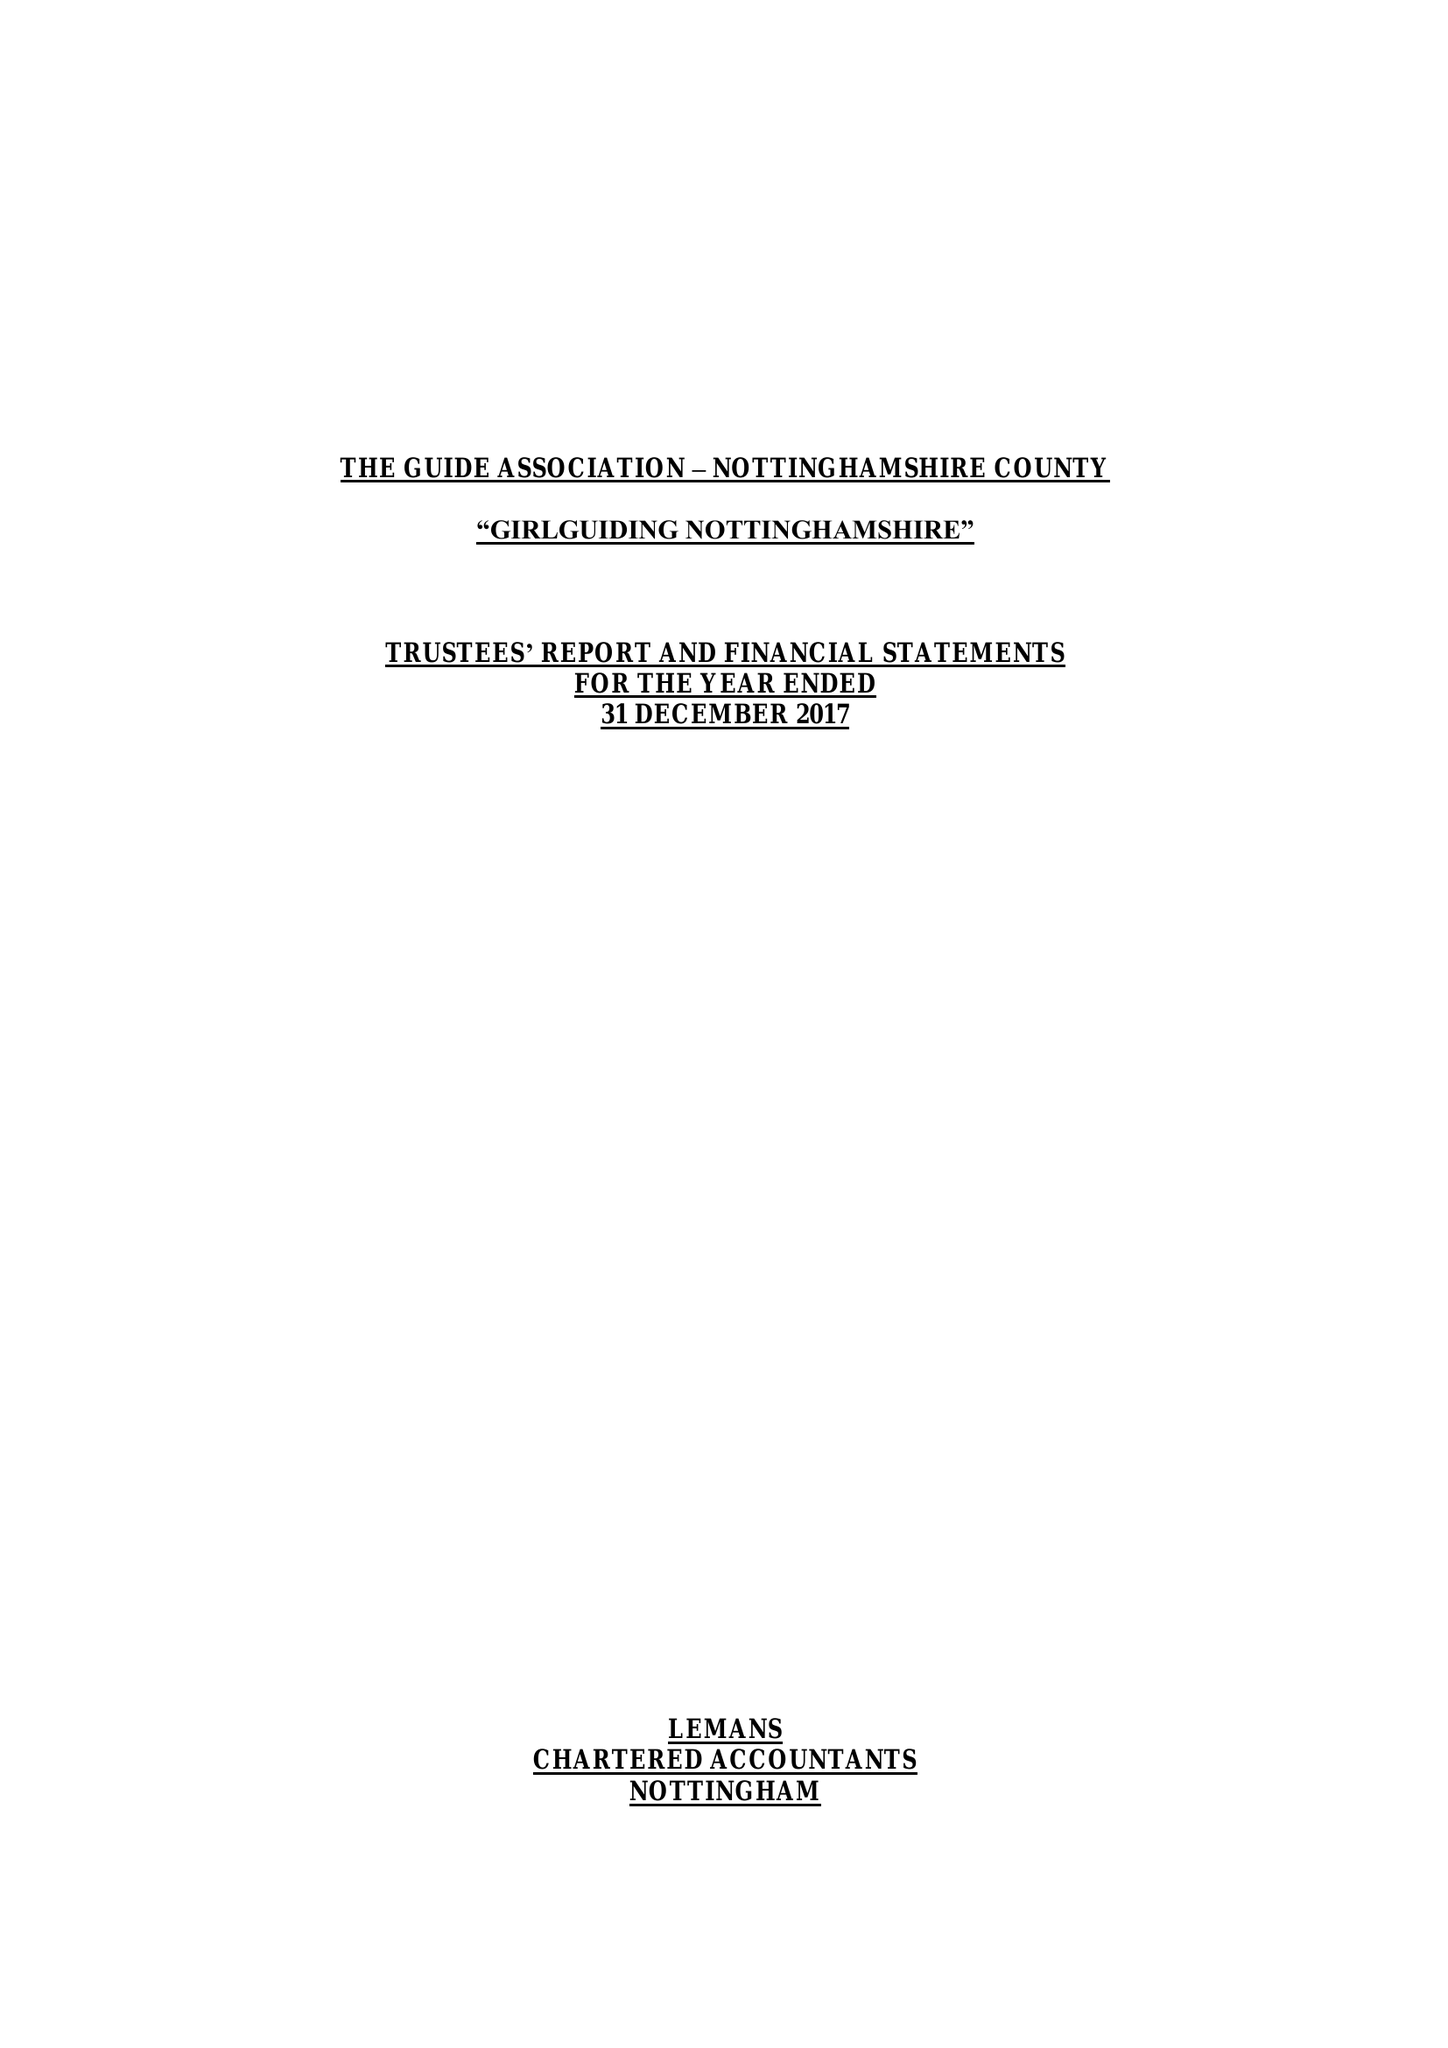What is the value for the spending_annually_in_british_pounds?
Answer the question using a single word or phrase. 224023.00 